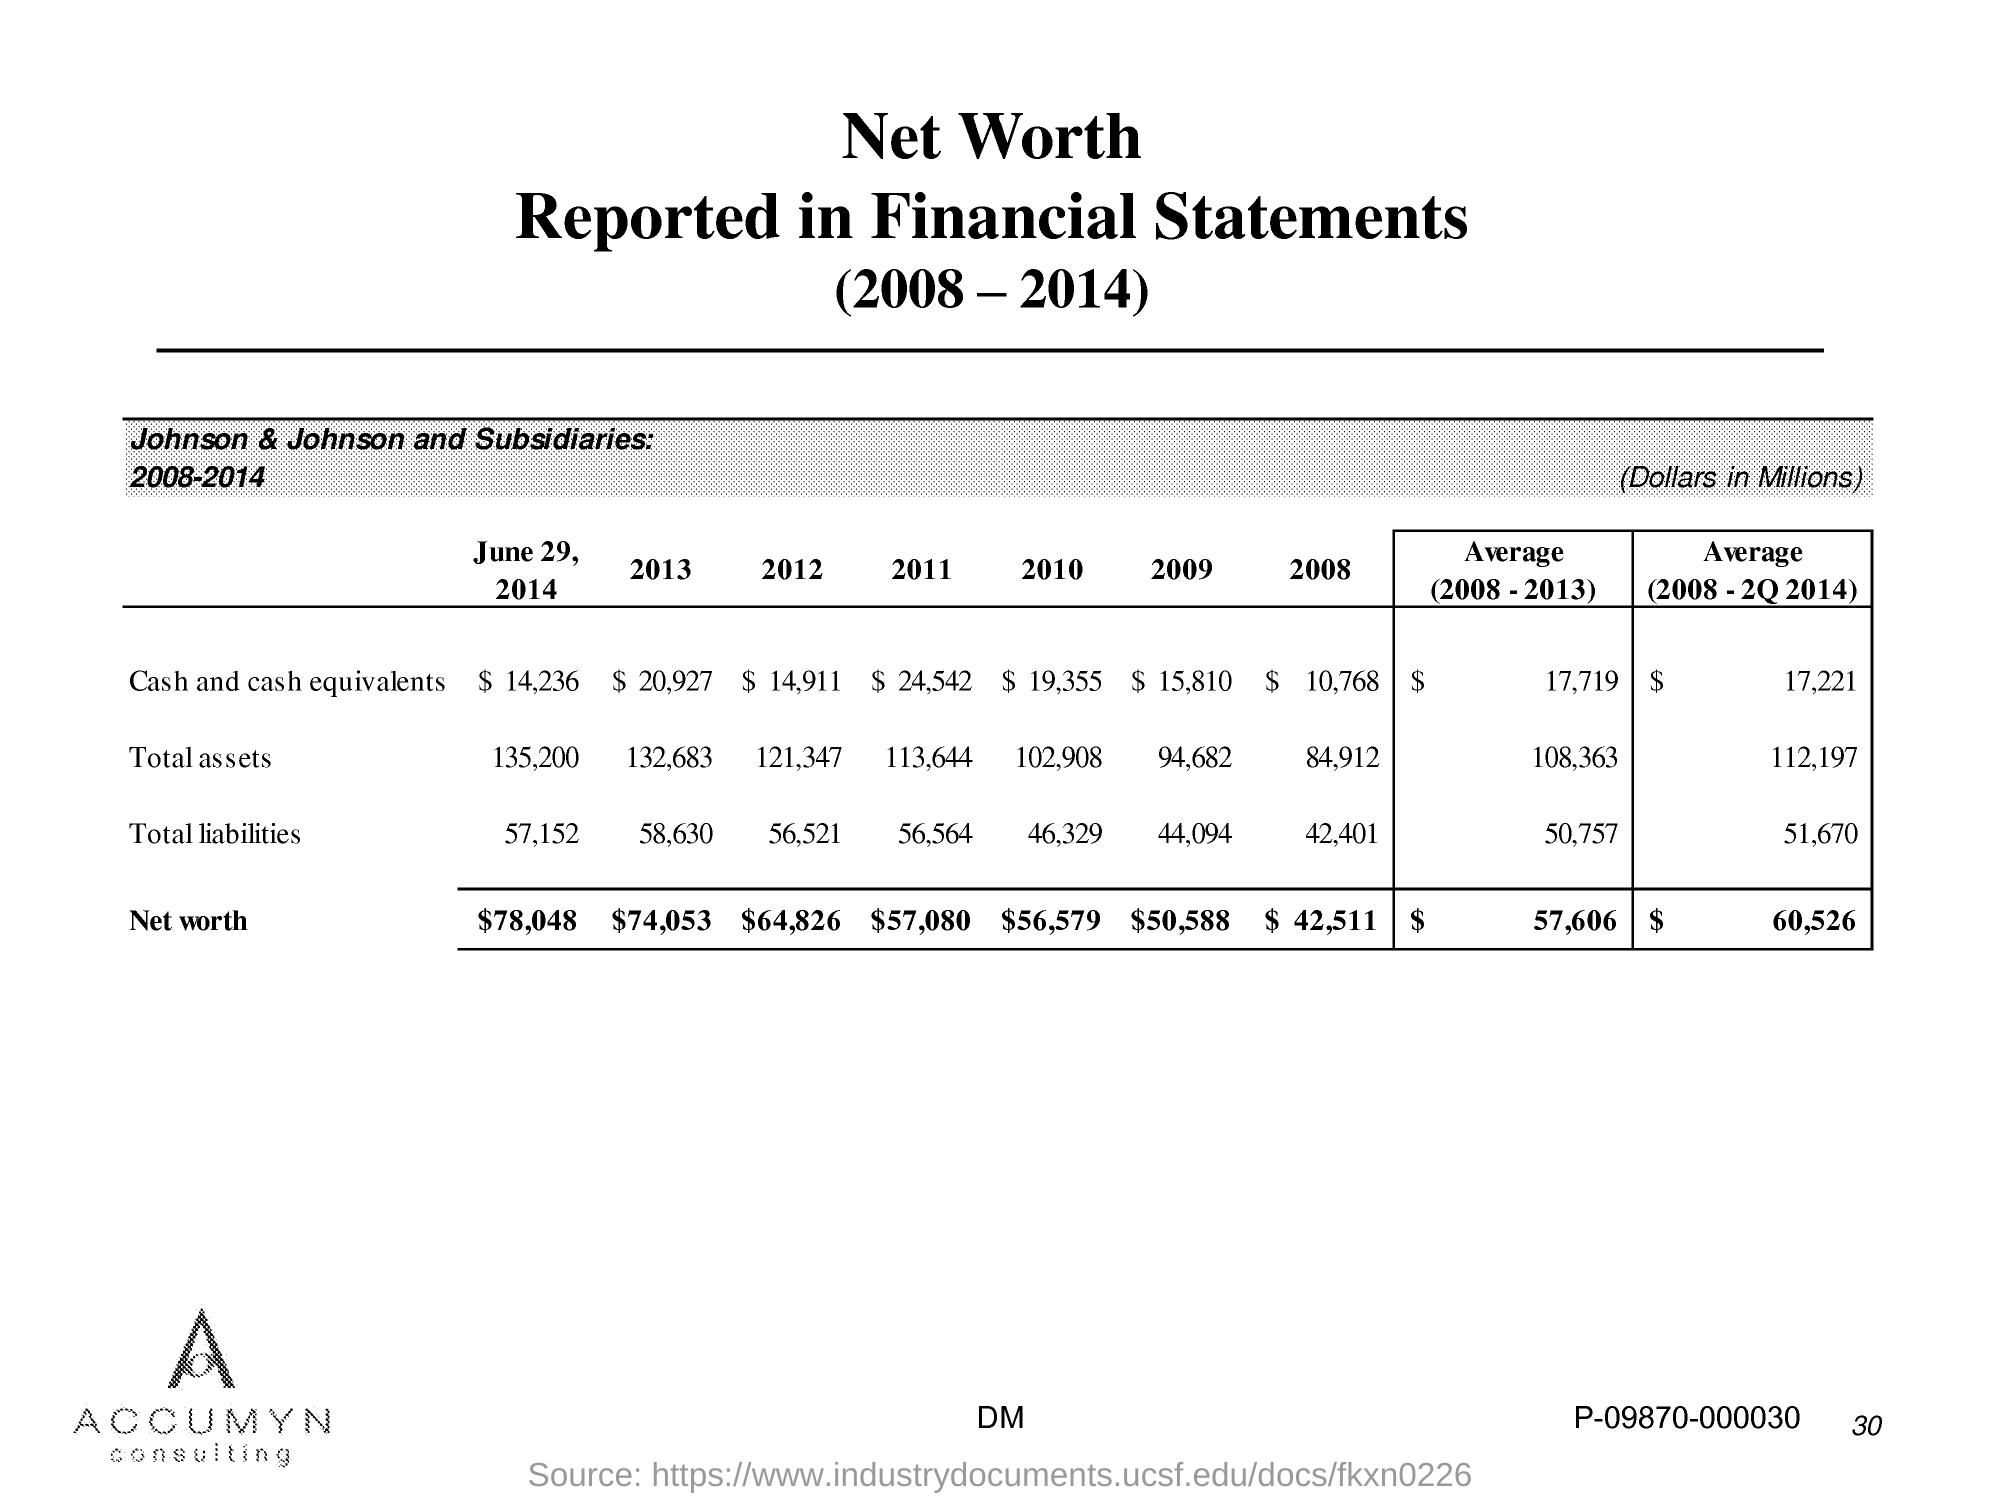What is the total assets in 2013?
Give a very brief answer. 132,683. What is the total assets in 2012?
Your answer should be very brief. 121,347. What is the total assets in 2011?
Offer a very short reply. 113,644. What is the total assets in 2010?
Your response must be concise. 102,908. What is the total assets in 2009 ?
Offer a terse response. 94,682. What is the total assets in 2008?
Provide a succinct answer. 84,912. What is the total liabilities in 2013?
Your answer should be very brief. 58,630. What is the total liabilities in 2012?
Provide a succinct answer. 56,521. What is the total liabilities in 2011?
Ensure brevity in your answer.  56,564. What is the total liabilities in 2010 ?
Ensure brevity in your answer.  46,329. 